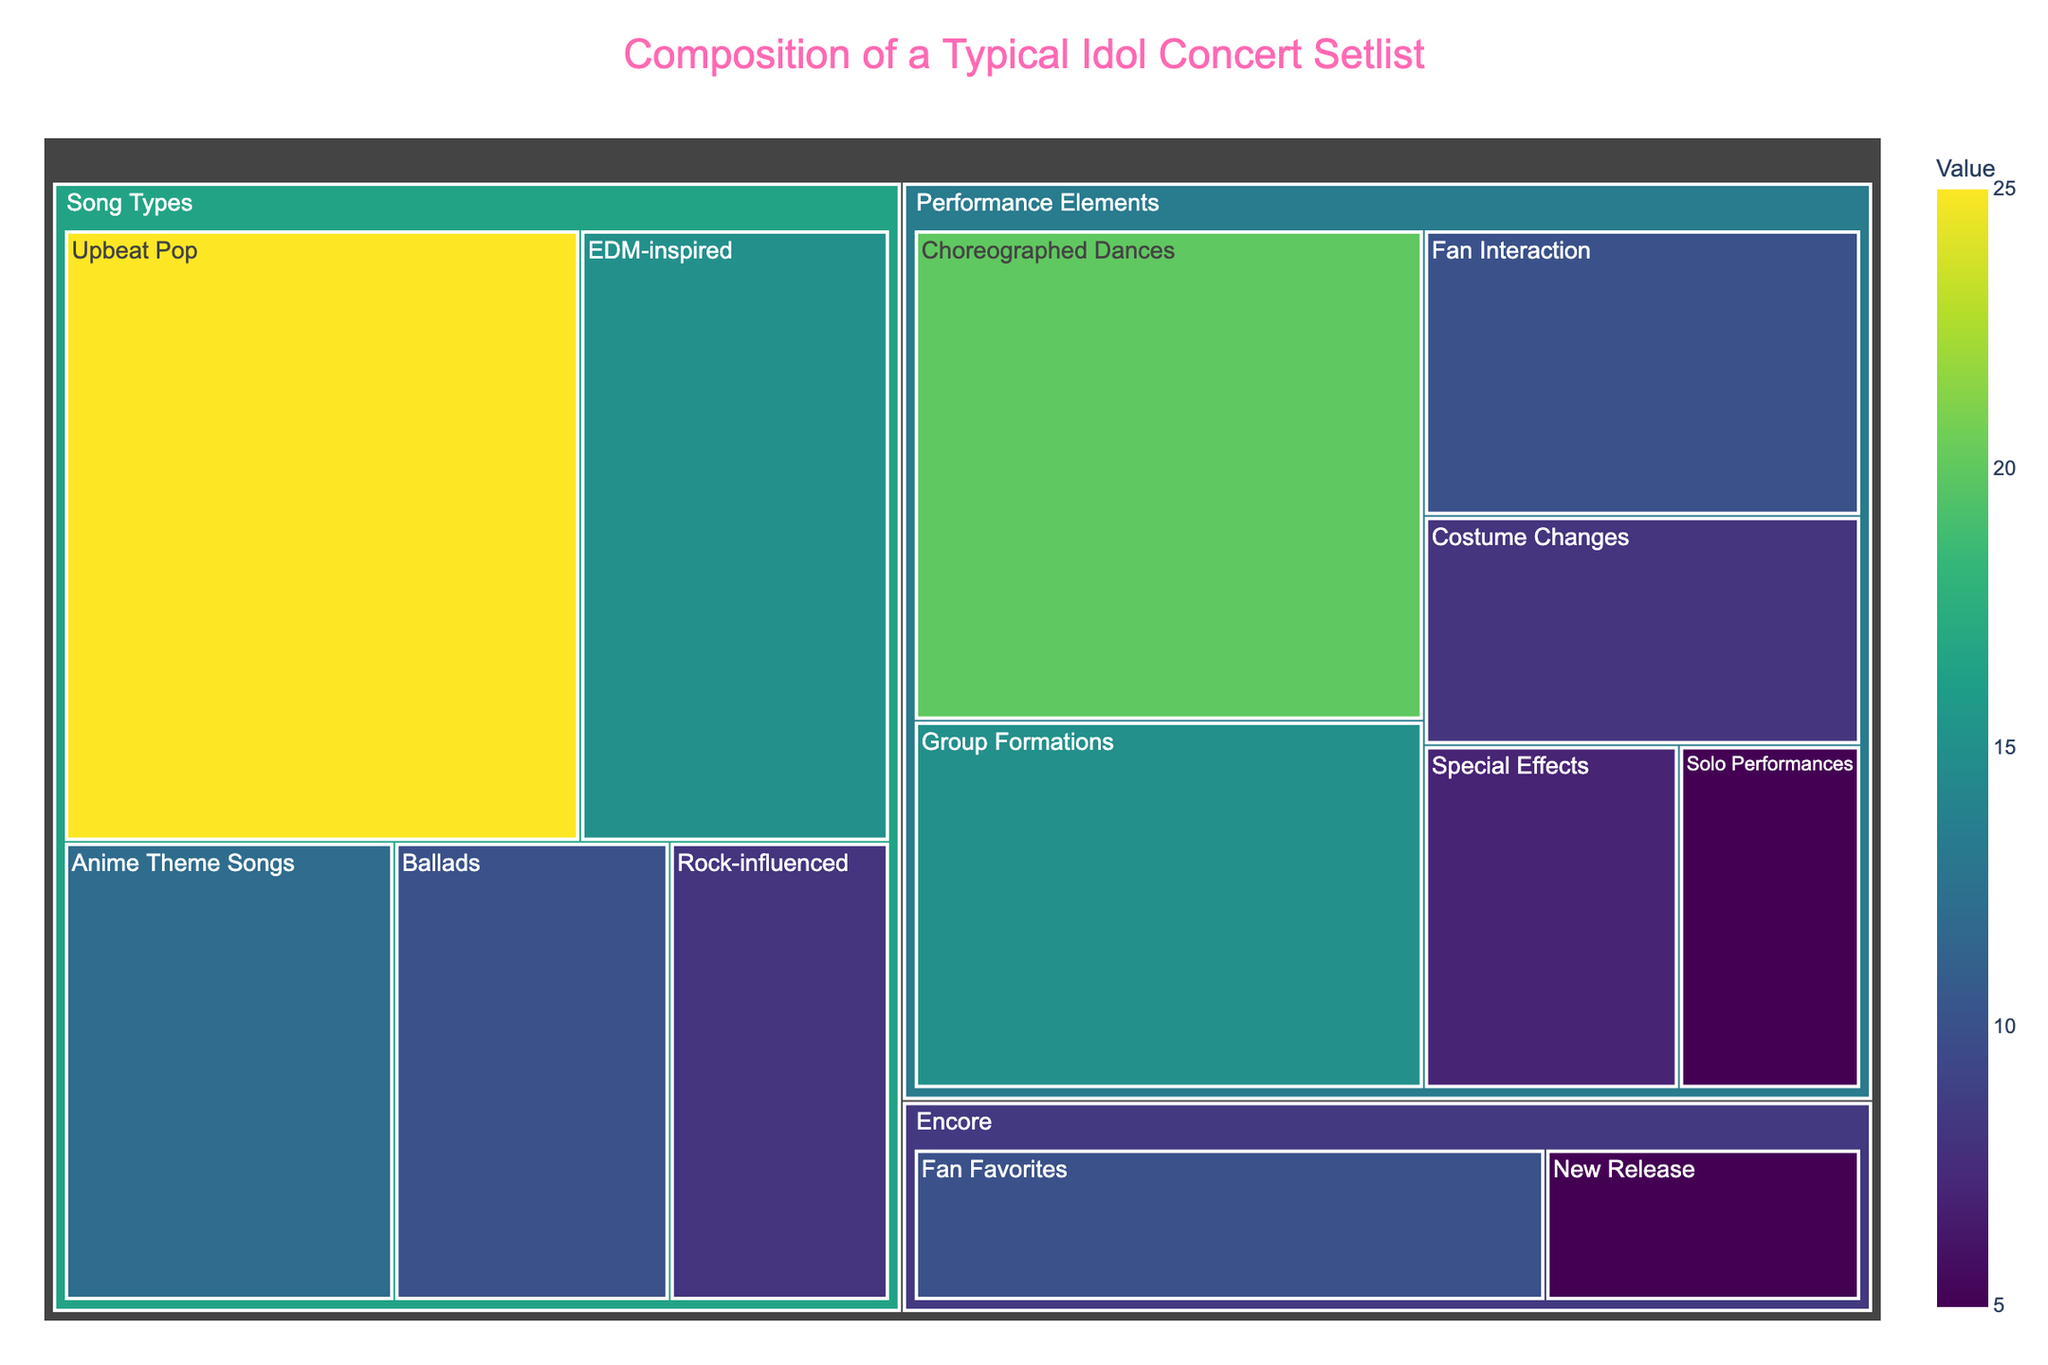what is the most frequent song type performance element in a typical idol concert setlist? given that the most frequent song types performance compared by value listed in the treemap under “song types”, the highest value which means the most frequent is upbeat pop with a value of 25
Answer: Upbeat Pop How many performance elements are there in the setlist? There are multiple elements listed in the treemap under the category 'Performance Elements'. They are Choreographed Dances, Solo Performances, Group Formations, Costume Changes, Fan Interaction, and Special Effects, making it a total of six elements.
Answer: Six Which category has the most variety of subcategories? By observing the treemap, the category 'Performance Elements' has the most subcategories, including Choreographed Dances, Solo Performances, Group Formations, Costume Changes, Fan Interaction, and Special Effects.
Answer: Performance Elements What is the total value for the 'Encore' category? Summing up the values for the subcategories under the 'Encore' category (Fan Favorites: 10 and New Release: 5), we get a total of 15.
Answer: 15 Among the song types, which has the least value? By comparing the values of all song types listed in the treemap, 'Rock-influenced’ has the least value of 8.
Answer: Rock-influenced What is the difference in value between the most and least popular performance elements? The 'Choreographed Dances' has the highest value of 20, and 'Special Effects' has the lowest value of 7. The difference is 20 - 7 = 13.
Answer: 13 What is the cumulative value of all 'Upbeat Pop' and 'EDM-inspired' performances? The value for 'Upbeat Pop' is 25, and for 'EDM-inspired' is 15. Adding these gives 25 + 15 = 40.
Answer: 40 Which performance element is closer in value to 'Fan Interaction'? 'Fan Interaction' has a value of 10. The closest value to this is 'Special Effects' with a value of 7.
Answer: Special Effects What is the average value of the subcategories under 'Performance Elements'? The values for 'Performance Elements' are 20, 5, 15, 8, 10, and 7. To find the average, sum them up (20 + 5 + 15 + 8 + 10 + 7 = 65) and divide by the number of elements (6). So, 65 / 6 ≈ 10.83.
Answer: 10.83 